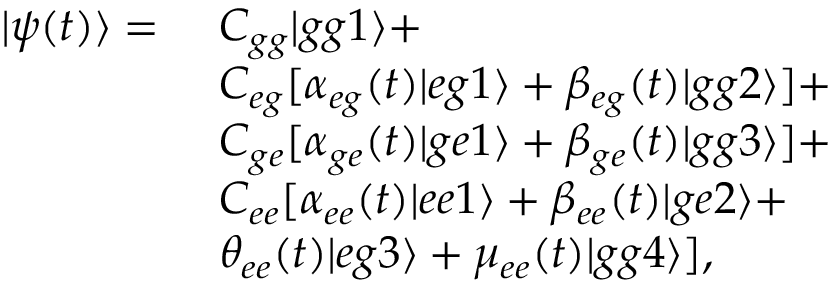<formula> <loc_0><loc_0><loc_500><loc_500>\begin{array} { r l } { | \psi ( t ) \rangle = } & { C _ { g g } | g g 1 \rangle + } \\ & { C _ { e g } [ \alpha _ { e g } ( t ) | e g 1 \rangle + \beta _ { e g } ( t ) | g g 2 \rangle ] + } \\ & { C _ { g e } [ \alpha _ { g e } ( t ) | g e 1 \rangle + \beta _ { g e } ( t ) | g g 3 \rangle ] + } \\ & { C _ { e e } [ \alpha _ { e e } ( t ) | e e 1 \rangle + \beta _ { e e } ( t ) | g e 2 \rangle + } \\ & { \theta _ { e e } ( t ) | e g 3 \rangle + \mu _ { e e } ( t ) | g g 4 \rangle ] , } \end{array}</formula> 